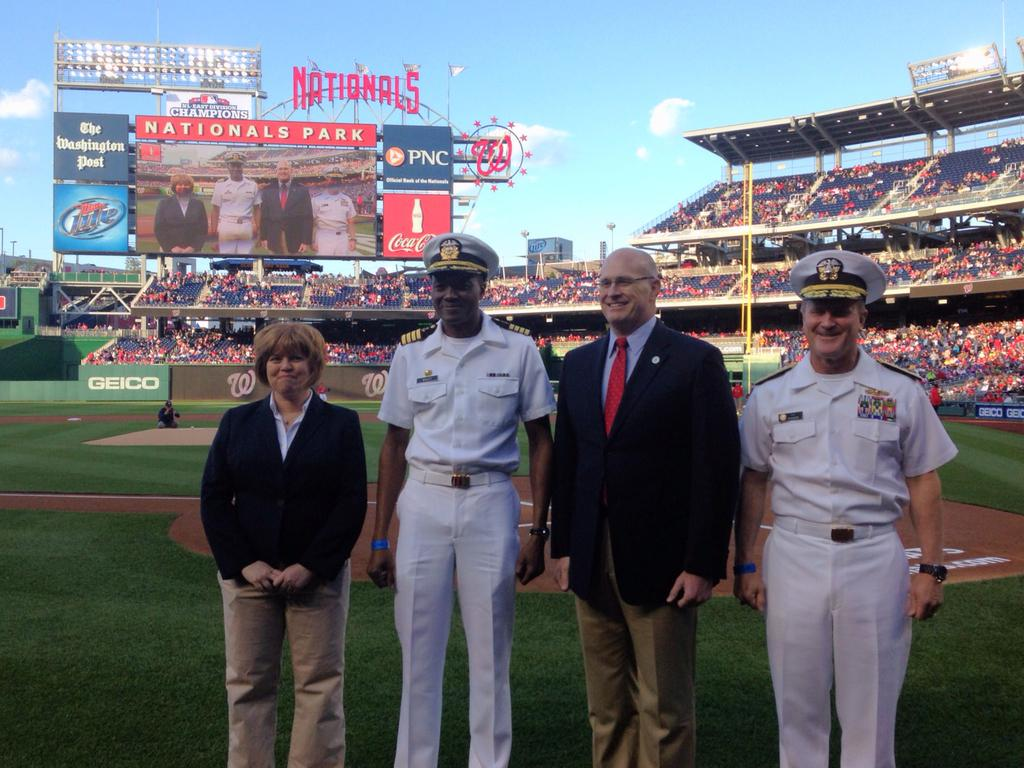<image>
Write a terse but informative summary of the picture. Two men in military uniform stand with 2 other on the field at Nationals Park. 